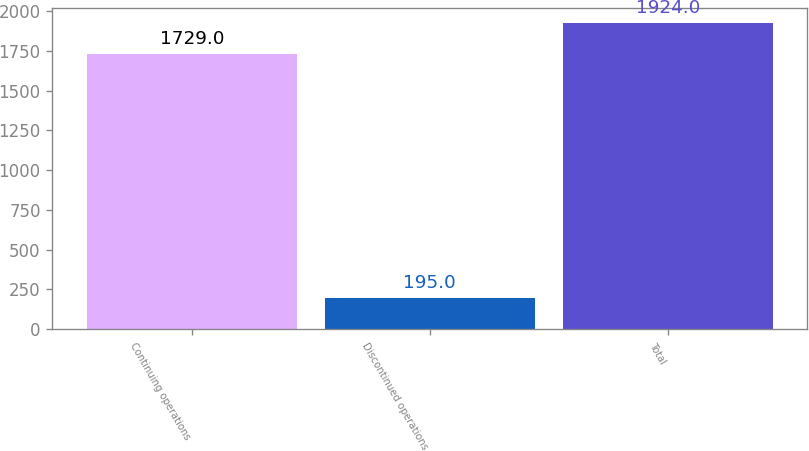<chart> <loc_0><loc_0><loc_500><loc_500><bar_chart><fcel>Continuing operations<fcel>Discontinued operations<fcel>Total<nl><fcel>1729<fcel>195<fcel>1924<nl></chart> 